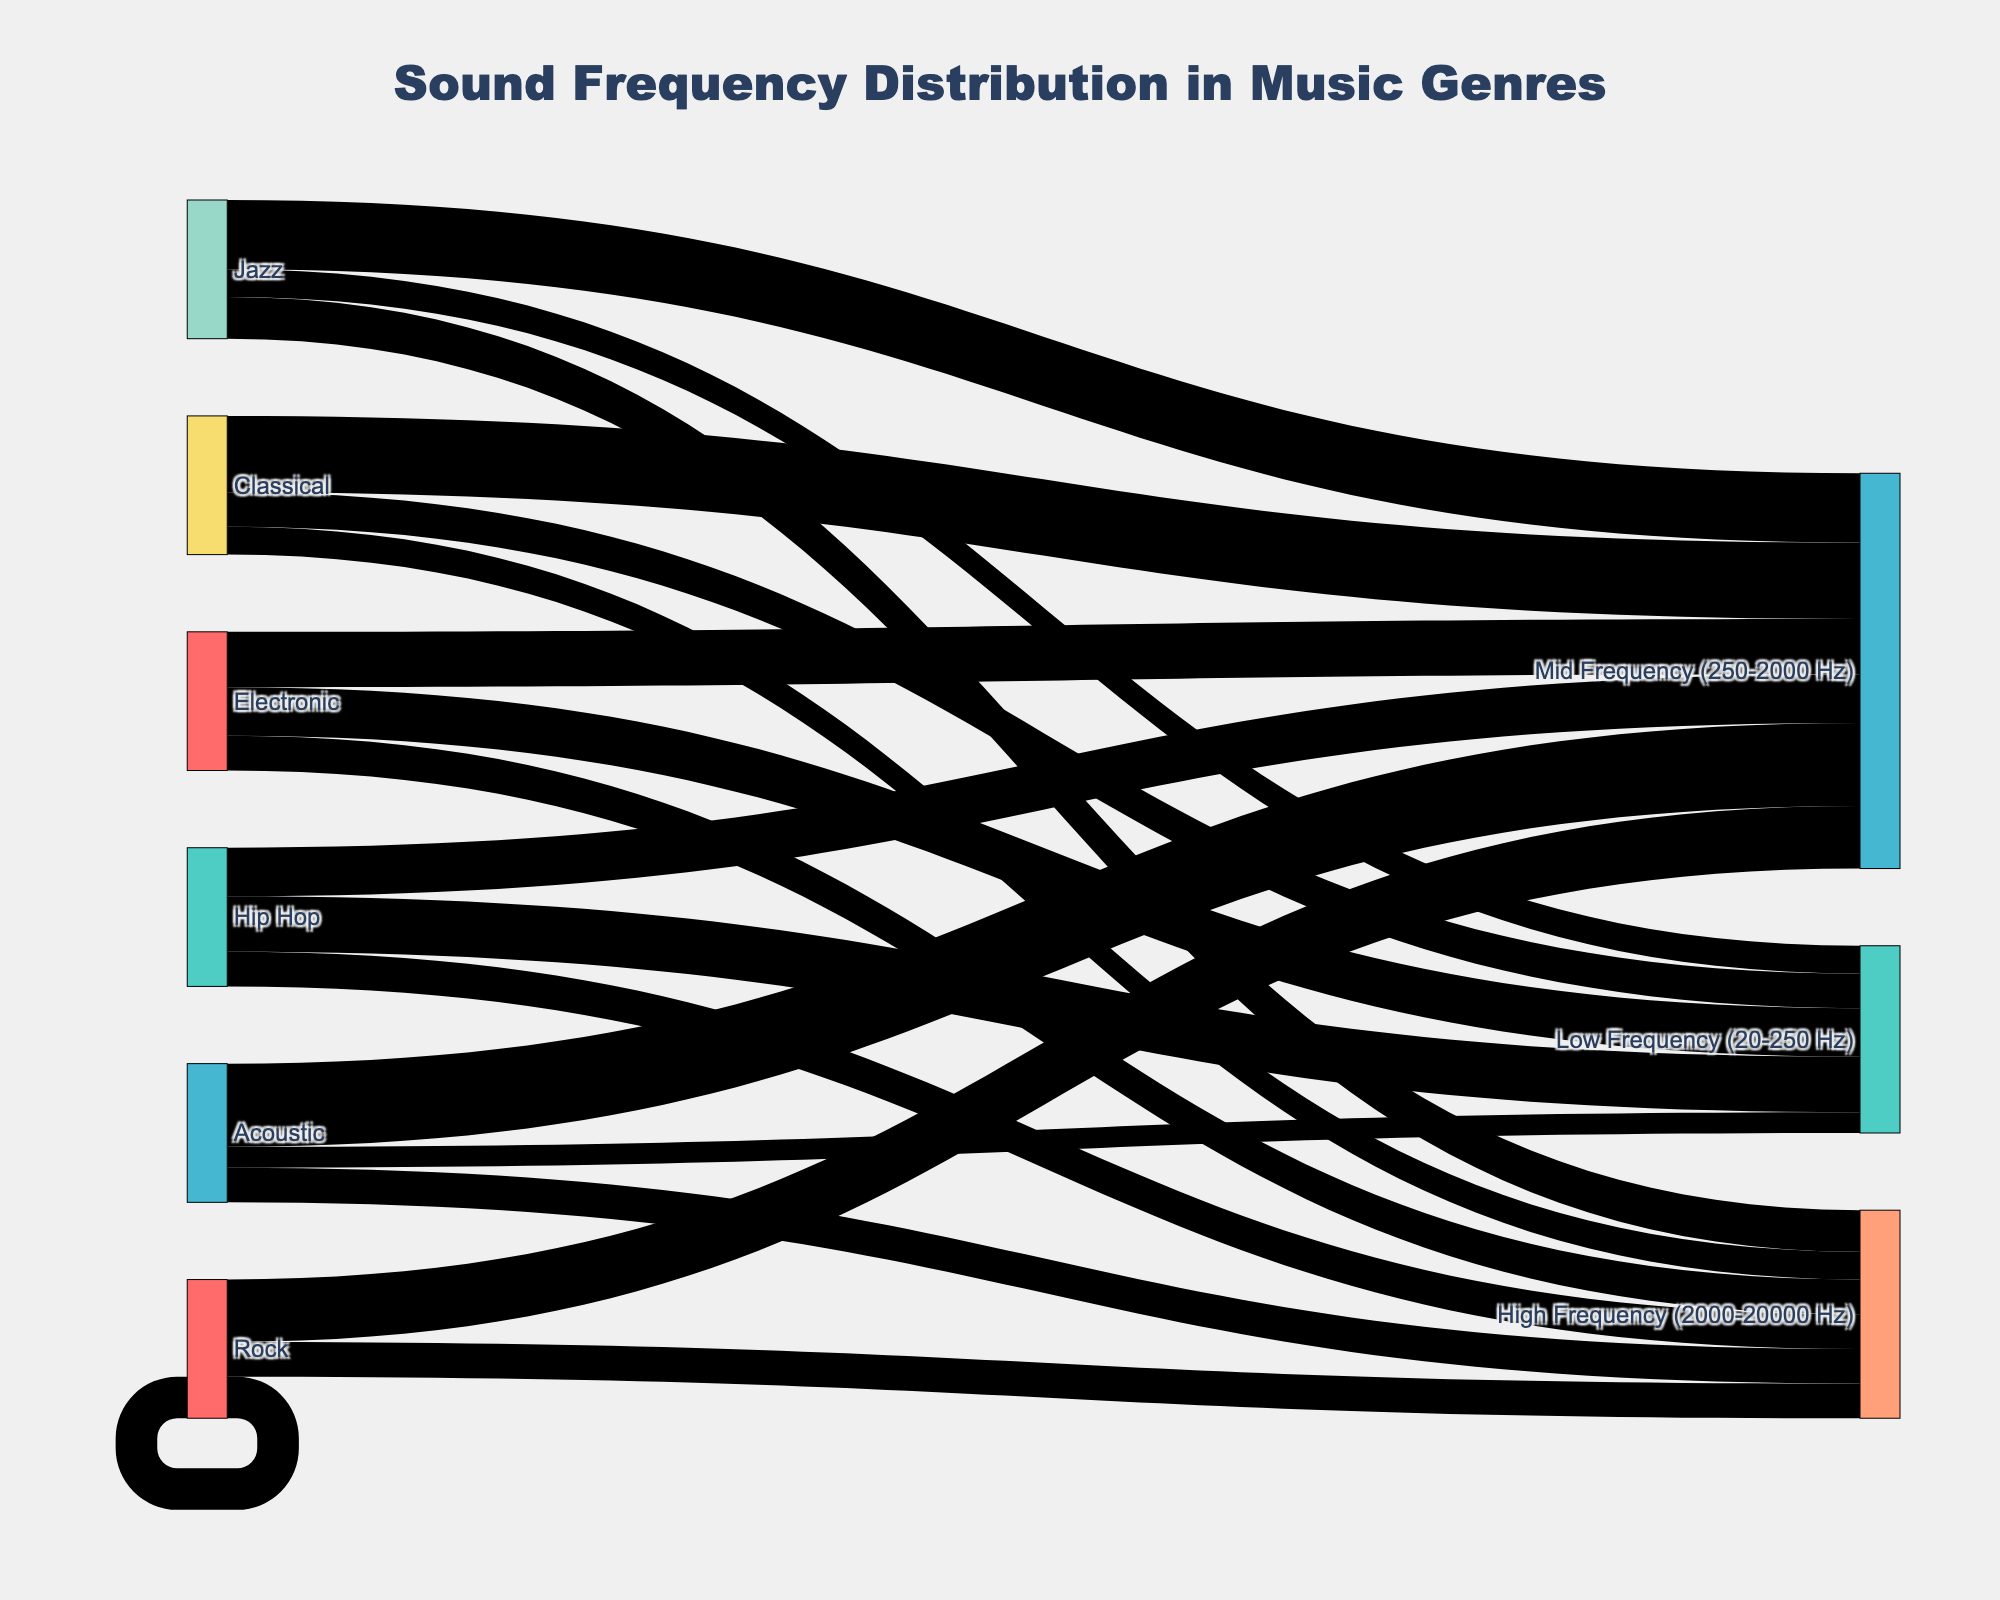what is the title of the figure? The title is typically found centered at the top of the figure and it reads: "Sound Frequency Distribution in Music Genres"
Answer: Sound Frequency Distribution in Music Genres Which genre has the highest contribution to the Low Frequency range? By examining the figure, look for the widest flow linking music genres to "Low Frequency (20-250 Hz)". Hip Hop has the highest contribution, with a value of 40.
Answer: Hip Hop How much higher is the Mid Frequency contribution in Classical music compared to Rock music? Observe the values of both genres for the "Mid Frequency (250-2000 Hz)" range. Classical music has 55 and Rock has 45, so the difference is 55 - 45 = 10.
Answer: 10 What genre has the least contribution to the High Frequency range? By comparing the widths of the flows to "High Frequency (2000-20000 Hz)" for each genre. Classical has the least with a value of 20.
Answer: Classical Which genre has the most balanced frequency distribution? Determine by checking for the smallest difference between the highest and lowest values across all three frequency ranges. Rock seems to have the most balanced distribution with values 30 (Low), 45 (Mid), 25 (High), having variations of 15 at most.
Answer: Rock How do the Low Frequency contributions of Jazz and Acoustic compare? Check the respective values for both genres in the Low Frequency range. Jazz has a value of 20 and Acoustic has 15. Jazz has a higher contribution.
Answer: Jazz has higher What is the total contribution to the Mid Frequency range from all genres combined? Sum the values linked to "Mid Frequency (250-2000 Hz)" for all genres: 45 (Rock) + 50 (Jazz) + 55 (Classical) + 40 (Electronic) + 35 (Hip Hop) + 60 (Acoustic) = 285.
Answer: 285 Which genre has equal contributions in High Frequency to another genre, if any? Look for genres with the same width of flows to "High Frequency (2000-20000 Hz)". Rock, Electronic, and Hip Hop all have an equal value of 25.
Answer: Rock, Electronic, and Hip Hop What is the average contribution across all genres to the Low Frequency range? Sum the contributions to Low Frequency range from all genres: 30 (Rock) + 20 (Jazz) + 25 (Classical) + 35 (Electronic) + 40 (Hip Hop) + 15 (Acoustic) = 165. Then divide by the 6 genres: 165 / 6 = 27.5.
Answer: 27.5 Compare the difference between the highest and lowest High Frequency contributions among the genres. Identify the highest (30 from Jazz) and the lowest (20 from Classical) values for High Frequency. The difference is 30 - 20 = 10.
Answer: 10 